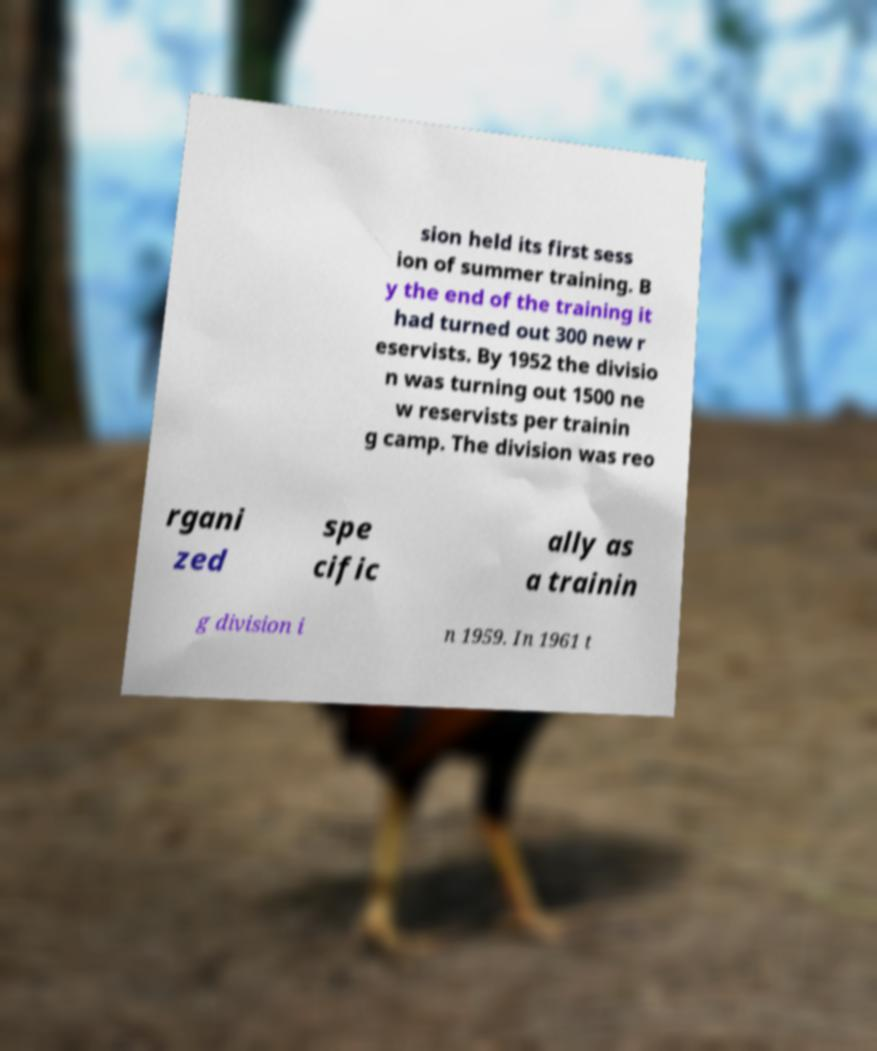Could you assist in decoding the text presented in this image and type it out clearly? sion held its first sess ion of summer training. B y the end of the training it had turned out 300 new r eservists. By 1952 the divisio n was turning out 1500 ne w reservists per trainin g camp. The division was reo rgani zed spe cific ally as a trainin g division i n 1959. In 1961 t 